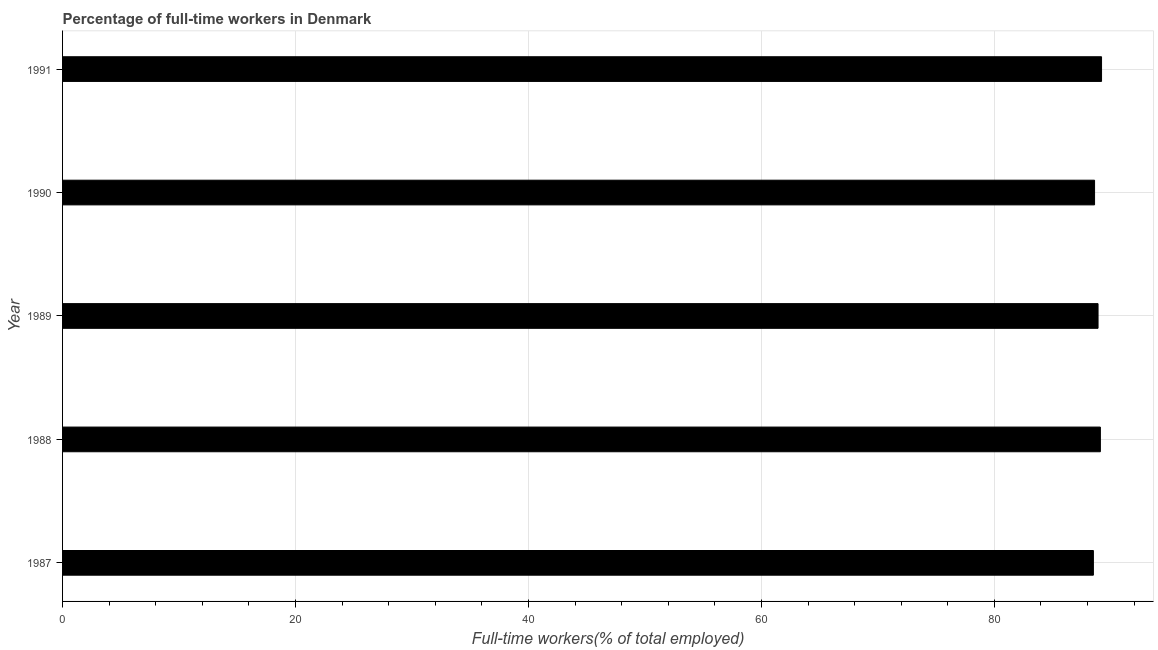What is the title of the graph?
Offer a terse response. Percentage of full-time workers in Denmark. What is the label or title of the X-axis?
Ensure brevity in your answer.  Full-time workers(% of total employed). What is the percentage of full-time workers in 1987?
Provide a short and direct response. 88.5. Across all years, what is the maximum percentage of full-time workers?
Provide a succinct answer. 89.2. Across all years, what is the minimum percentage of full-time workers?
Offer a terse response. 88.5. In which year was the percentage of full-time workers maximum?
Keep it short and to the point. 1991. What is the sum of the percentage of full-time workers?
Give a very brief answer. 444.3. What is the average percentage of full-time workers per year?
Your answer should be compact. 88.86. What is the median percentage of full-time workers?
Offer a terse response. 88.9. In how many years, is the percentage of full-time workers greater than 36 %?
Offer a very short reply. 5. Is the percentage of full-time workers in 1989 less than that in 1990?
Ensure brevity in your answer.  No. In how many years, is the percentage of full-time workers greater than the average percentage of full-time workers taken over all years?
Your answer should be very brief. 3. How many years are there in the graph?
Keep it short and to the point. 5. What is the difference between two consecutive major ticks on the X-axis?
Give a very brief answer. 20. Are the values on the major ticks of X-axis written in scientific E-notation?
Keep it short and to the point. No. What is the Full-time workers(% of total employed) of 1987?
Your answer should be compact. 88.5. What is the Full-time workers(% of total employed) in 1988?
Keep it short and to the point. 89.1. What is the Full-time workers(% of total employed) of 1989?
Keep it short and to the point. 88.9. What is the Full-time workers(% of total employed) of 1990?
Offer a very short reply. 88.6. What is the Full-time workers(% of total employed) in 1991?
Give a very brief answer. 89.2. What is the difference between the Full-time workers(% of total employed) in 1988 and 1989?
Give a very brief answer. 0.2. What is the difference between the Full-time workers(% of total employed) in 1988 and 1990?
Provide a succinct answer. 0.5. What is the difference between the Full-time workers(% of total employed) in 1989 and 1990?
Provide a short and direct response. 0.3. What is the difference between the Full-time workers(% of total employed) in 1989 and 1991?
Offer a very short reply. -0.3. What is the difference between the Full-time workers(% of total employed) in 1990 and 1991?
Ensure brevity in your answer.  -0.6. What is the ratio of the Full-time workers(% of total employed) in 1987 to that in 1989?
Your answer should be compact. 1. What is the ratio of the Full-time workers(% of total employed) in 1987 to that in 1991?
Provide a short and direct response. 0.99. What is the ratio of the Full-time workers(% of total employed) in 1988 to that in 1989?
Your answer should be very brief. 1. What is the ratio of the Full-time workers(% of total employed) in 1989 to that in 1991?
Ensure brevity in your answer.  1. 